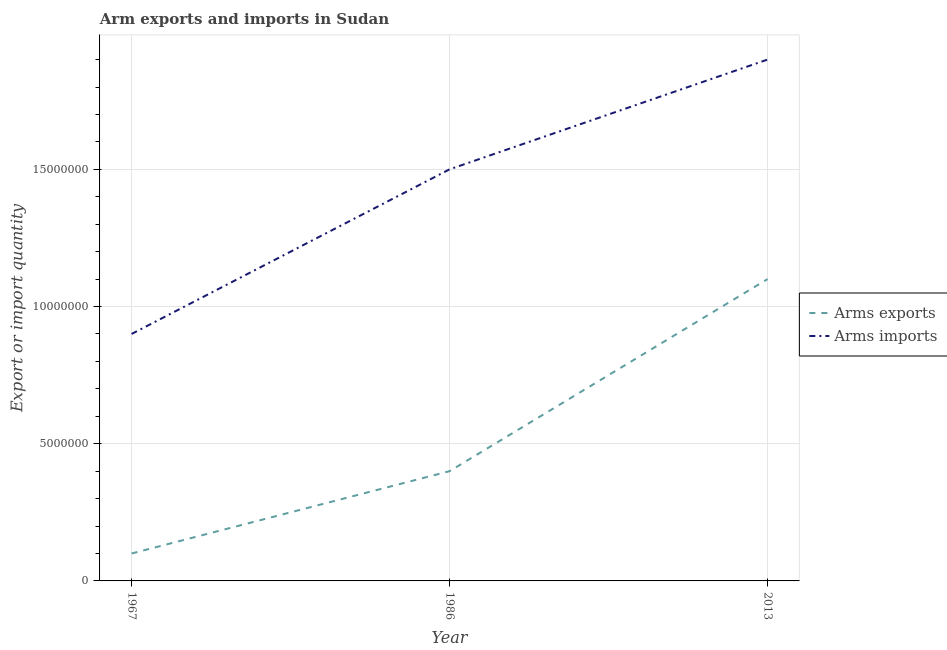Does the line corresponding to arms exports intersect with the line corresponding to arms imports?
Your response must be concise. No. Is the number of lines equal to the number of legend labels?
Offer a very short reply. Yes. What is the arms imports in 1967?
Ensure brevity in your answer.  9.00e+06. Across all years, what is the maximum arms exports?
Offer a terse response. 1.10e+07. Across all years, what is the minimum arms exports?
Provide a short and direct response. 1.00e+06. In which year was the arms exports minimum?
Offer a terse response. 1967. What is the total arms exports in the graph?
Your answer should be compact. 1.60e+07. What is the difference between the arms imports in 1967 and that in 2013?
Provide a short and direct response. -1.00e+07. What is the difference between the arms exports in 2013 and the arms imports in 1967?
Make the answer very short. 2.00e+06. What is the average arms imports per year?
Provide a short and direct response. 1.43e+07. In the year 1967, what is the difference between the arms exports and arms imports?
Your answer should be compact. -8.00e+06. In how many years, is the arms imports greater than 3000000?
Your response must be concise. 3. What is the ratio of the arms exports in 1967 to that in 1986?
Your answer should be compact. 0.25. What is the difference between the highest and the second highest arms imports?
Your response must be concise. 4.00e+06. What is the difference between the highest and the lowest arms exports?
Provide a short and direct response. 1.00e+07. In how many years, is the arms imports greater than the average arms imports taken over all years?
Your response must be concise. 2. Is the arms imports strictly greater than the arms exports over the years?
Ensure brevity in your answer.  Yes. How many years are there in the graph?
Provide a succinct answer. 3. What is the difference between two consecutive major ticks on the Y-axis?
Make the answer very short. 5.00e+06. Where does the legend appear in the graph?
Your response must be concise. Center right. How many legend labels are there?
Make the answer very short. 2. What is the title of the graph?
Your answer should be very brief. Arm exports and imports in Sudan. Does "Official creditors" appear as one of the legend labels in the graph?
Your response must be concise. No. What is the label or title of the Y-axis?
Provide a succinct answer. Export or import quantity. What is the Export or import quantity of Arms exports in 1967?
Your response must be concise. 1.00e+06. What is the Export or import quantity in Arms imports in 1967?
Keep it short and to the point. 9.00e+06. What is the Export or import quantity of Arms imports in 1986?
Your answer should be compact. 1.50e+07. What is the Export or import quantity in Arms exports in 2013?
Give a very brief answer. 1.10e+07. What is the Export or import quantity in Arms imports in 2013?
Offer a terse response. 1.90e+07. Across all years, what is the maximum Export or import quantity in Arms exports?
Offer a terse response. 1.10e+07. Across all years, what is the maximum Export or import quantity of Arms imports?
Ensure brevity in your answer.  1.90e+07. Across all years, what is the minimum Export or import quantity of Arms exports?
Provide a short and direct response. 1.00e+06. Across all years, what is the minimum Export or import quantity in Arms imports?
Offer a very short reply. 9.00e+06. What is the total Export or import quantity of Arms exports in the graph?
Provide a short and direct response. 1.60e+07. What is the total Export or import quantity of Arms imports in the graph?
Your response must be concise. 4.30e+07. What is the difference between the Export or import quantity of Arms exports in 1967 and that in 1986?
Offer a very short reply. -3.00e+06. What is the difference between the Export or import quantity of Arms imports in 1967 and that in 1986?
Ensure brevity in your answer.  -6.00e+06. What is the difference between the Export or import quantity of Arms exports in 1967 and that in 2013?
Your response must be concise. -1.00e+07. What is the difference between the Export or import quantity of Arms imports in 1967 and that in 2013?
Make the answer very short. -1.00e+07. What is the difference between the Export or import quantity of Arms exports in 1986 and that in 2013?
Give a very brief answer. -7.00e+06. What is the difference between the Export or import quantity of Arms exports in 1967 and the Export or import quantity of Arms imports in 1986?
Provide a short and direct response. -1.40e+07. What is the difference between the Export or import quantity of Arms exports in 1967 and the Export or import quantity of Arms imports in 2013?
Your answer should be compact. -1.80e+07. What is the difference between the Export or import quantity in Arms exports in 1986 and the Export or import quantity in Arms imports in 2013?
Your response must be concise. -1.50e+07. What is the average Export or import quantity of Arms exports per year?
Offer a very short reply. 5.33e+06. What is the average Export or import quantity of Arms imports per year?
Your answer should be very brief. 1.43e+07. In the year 1967, what is the difference between the Export or import quantity of Arms exports and Export or import quantity of Arms imports?
Ensure brevity in your answer.  -8.00e+06. In the year 1986, what is the difference between the Export or import quantity in Arms exports and Export or import quantity in Arms imports?
Offer a terse response. -1.10e+07. In the year 2013, what is the difference between the Export or import quantity in Arms exports and Export or import quantity in Arms imports?
Provide a succinct answer. -8.00e+06. What is the ratio of the Export or import quantity of Arms exports in 1967 to that in 1986?
Give a very brief answer. 0.25. What is the ratio of the Export or import quantity of Arms exports in 1967 to that in 2013?
Your response must be concise. 0.09. What is the ratio of the Export or import quantity in Arms imports in 1967 to that in 2013?
Make the answer very short. 0.47. What is the ratio of the Export or import quantity in Arms exports in 1986 to that in 2013?
Offer a terse response. 0.36. What is the ratio of the Export or import quantity in Arms imports in 1986 to that in 2013?
Your answer should be very brief. 0.79. What is the difference between the highest and the second highest Export or import quantity of Arms exports?
Your answer should be very brief. 7.00e+06. What is the difference between the highest and the lowest Export or import quantity of Arms imports?
Give a very brief answer. 1.00e+07. 